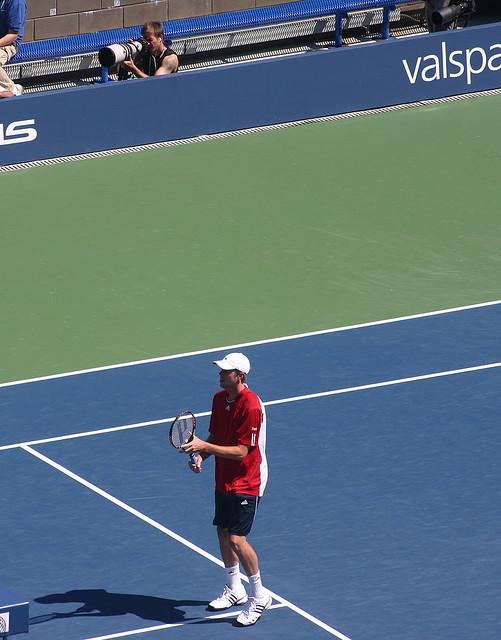Is the player standing near the net?
Give a very brief answer. No. What color is the court?
Write a very short answer. Blue. What is the man playing?
Write a very short answer. Tennis. Is this tennis player making a lot of effort to win the match?
Write a very short answer. Yes. What company has marketing placed around the court?
Keep it brief. Valspar. 